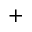<formula> <loc_0><loc_0><loc_500><loc_500>+</formula> 